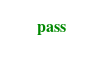Convert code to text. <code><loc_0><loc_0><loc_500><loc_500><_Python_>    pass
</code> 